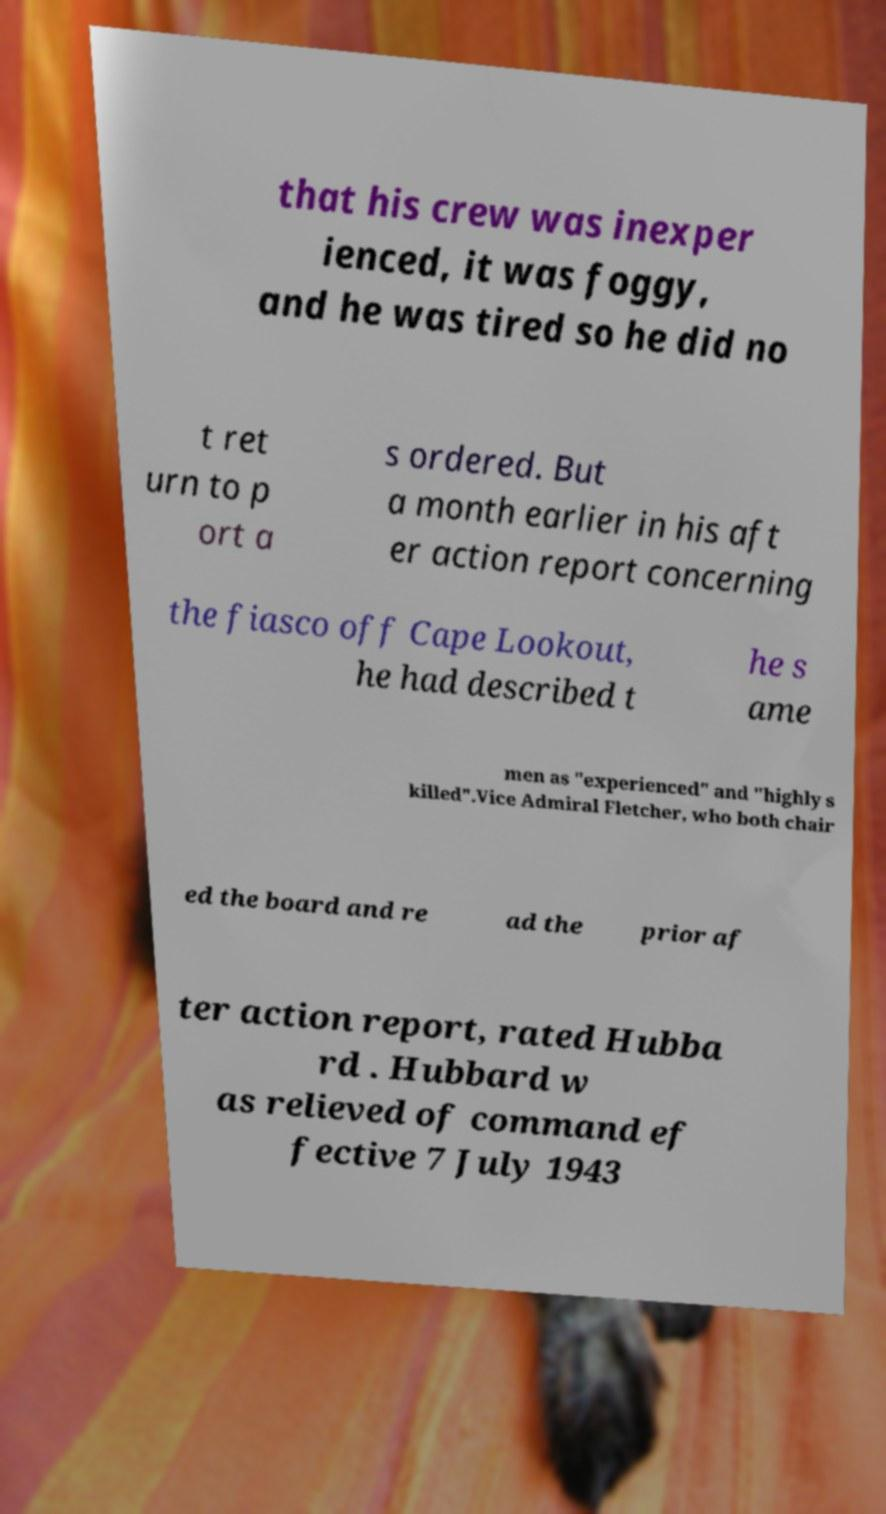Could you assist in decoding the text presented in this image and type it out clearly? that his crew was inexper ienced, it was foggy, and he was tired so he did no t ret urn to p ort a s ordered. But a month earlier in his aft er action report concerning the fiasco off Cape Lookout, he had described t he s ame men as "experienced" and "highly s killed".Vice Admiral Fletcher, who both chair ed the board and re ad the prior af ter action report, rated Hubba rd . Hubbard w as relieved of command ef fective 7 July 1943 